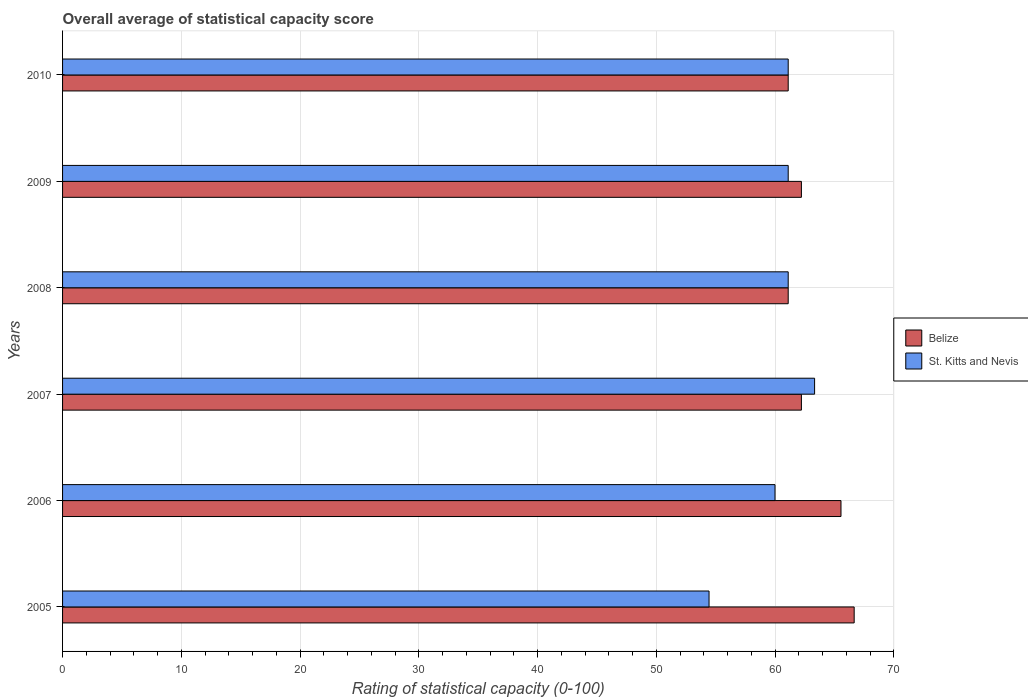How many groups of bars are there?
Provide a succinct answer. 6. Are the number of bars per tick equal to the number of legend labels?
Provide a short and direct response. Yes. Are the number of bars on each tick of the Y-axis equal?
Provide a succinct answer. Yes. How many bars are there on the 2nd tick from the top?
Provide a succinct answer. 2. How many bars are there on the 3rd tick from the bottom?
Your answer should be compact. 2. What is the label of the 4th group of bars from the top?
Keep it short and to the point. 2007. In how many cases, is the number of bars for a given year not equal to the number of legend labels?
Make the answer very short. 0. What is the rating of statistical capacity in St. Kitts and Nevis in 2008?
Provide a short and direct response. 61.11. Across all years, what is the maximum rating of statistical capacity in Belize?
Your answer should be very brief. 66.67. Across all years, what is the minimum rating of statistical capacity in Belize?
Give a very brief answer. 61.11. What is the total rating of statistical capacity in St. Kitts and Nevis in the graph?
Offer a very short reply. 361.11. What is the difference between the rating of statistical capacity in Belize in 2005 and that in 2008?
Your response must be concise. 5.56. What is the difference between the rating of statistical capacity in Belize in 2010 and the rating of statistical capacity in St. Kitts and Nevis in 2008?
Offer a very short reply. 0. What is the average rating of statistical capacity in Belize per year?
Your answer should be very brief. 63.15. In the year 2010, what is the difference between the rating of statistical capacity in Belize and rating of statistical capacity in St. Kitts and Nevis?
Ensure brevity in your answer.  0. What is the ratio of the rating of statistical capacity in Belize in 2005 to that in 2006?
Provide a short and direct response. 1.02. What is the difference between the highest and the second highest rating of statistical capacity in Belize?
Give a very brief answer. 1.11. What is the difference between the highest and the lowest rating of statistical capacity in St. Kitts and Nevis?
Keep it short and to the point. 8.89. What does the 2nd bar from the top in 2006 represents?
Your answer should be compact. Belize. What does the 2nd bar from the bottom in 2010 represents?
Keep it short and to the point. St. Kitts and Nevis. Are all the bars in the graph horizontal?
Keep it short and to the point. Yes. Are the values on the major ticks of X-axis written in scientific E-notation?
Offer a very short reply. No. Does the graph contain any zero values?
Your answer should be very brief. No. Does the graph contain grids?
Your answer should be compact. Yes. Where does the legend appear in the graph?
Ensure brevity in your answer.  Center right. How many legend labels are there?
Your answer should be very brief. 2. What is the title of the graph?
Provide a short and direct response. Overall average of statistical capacity score. Does "Puerto Rico" appear as one of the legend labels in the graph?
Make the answer very short. No. What is the label or title of the X-axis?
Provide a short and direct response. Rating of statistical capacity (0-100). What is the label or title of the Y-axis?
Provide a succinct answer. Years. What is the Rating of statistical capacity (0-100) of Belize in 2005?
Provide a succinct answer. 66.67. What is the Rating of statistical capacity (0-100) of St. Kitts and Nevis in 2005?
Offer a very short reply. 54.44. What is the Rating of statistical capacity (0-100) of Belize in 2006?
Provide a short and direct response. 65.56. What is the Rating of statistical capacity (0-100) of Belize in 2007?
Make the answer very short. 62.22. What is the Rating of statistical capacity (0-100) in St. Kitts and Nevis in 2007?
Your response must be concise. 63.33. What is the Rating of statistical capacity (0-100) in Belize in 2008?
Keep it short and to the point. 61.11. What is the Rating of statistical capacity (0-100) in St. Kitts and Nevis in 2008?
Provide a succinct answer. 61.11. What is the Rating of statistical capacity (0-100) of Belize in 2009?
Ensure brevity in your answer.  62.22. What is the Rating of statistical capacity (0-100) in St. Kitts and Nevis in 2009?
Provide a succinct answer. 61.11. What is the Rating of statistical capacity (0-100) of Belize in 2010?
Ensure brevity in your answer.  61.11. What is the Rating of statistical capacity (0-100) in St. Kitts and Nevis in 2010?
Your answer should be very brief. 61.11. Across all years, what is the maximum Rating of statistical capacity (0-100) of Belize?
Provide a succinct answer. 66.67. Across all years, what is the maximum Rating of statistical capacity (0-100) of St. Kitts and Nevis?
Ensure brevity in your answer.  63.33. Across all years, what is the minimum Rating of statistical capacity (0-100) in Belize?
Offer a terse response. 61.11. Across all years, what is the minimum Rating of statistical capacity (0-100) in St. Kitts and Nevis?
Provide a short and direct response. 54.44. What is the total Rating of statistical capacity (0-100) of Belize in the graph?
Offer a very short reply. 378.89. What is the total Rating of statistical capacity (0-100) in St. Kitts and Nevis in the graph?
Keep it short and to the point. 361.11. What is the difference between the Rating of statistical capacity (0-100) of St. Kitts and Nevis in 2005 and that in 2006?
Your answer should be very brief. -5.56. What is the difference between the Rating of statistical capacity (0-100) of Belize in 2005 and that in 2007?
Ensure brevity in your answer.  4.44. What is the difference between the Rating of statistical capacity (0-100) of St. Kitts and Nevis in 2005 and that in 2007?
Your answer should be very brief. -8.89. What is the difference between the Rating of statistical capacity (0-100) in Belize in 2005 and that in 2008?
Offer a terse response. 5.56. What is the difference between the Rating of statistical capacity (0-100) of St. Kitts and Nevis in 2005 and that in 2008?
Keep it short and to the point. -6.67. What is the difference between the Rating of statistical capacity (0-100) in Belize in 2005 and that in 2009?
Offer a terse response. 4.44. What is the difference between the Rating of statistical capacity (0-100) in St. Kitts and Nevis in 2005 and that in 2009?
Your response must be concise. -6.67. What is the difference between the Rating of statistical capacity (0-100) of Belize in 2005 and that in 2010?
Give a very brief answer. 5.56. What is the difference between the Rating of statistical capacity (0-100) of St. Kitts and Nevis in 2005 and that in 2010?
Ensure brevity in your answer.  -6.67. What is the difference between the Rating of statistical capacity (0-100) in Belize in 2006 and that in 2008?
Keep it short and to the point. 4.44. What is the difference between the Rating of statistical capacity (0-100) of St. Kitts and Nevis in 2006 and that in 2008?
Ensure brevity in your answer.  -1.11. What is the difference between the Rating of statistical capacity (0-100) in St. Kitts and Nevis in 2006 and that in 2009?
Give a very brief answer. -1.11. What is the difference between the Rating of statistical capacity (0-100) in Belize in 2006 and that in 2010?
Give a very brief answer. 4.44. What is the difference between the Rating of statistical capacity (0-100) in St. Kitts and Nevis in 2006 and that in 2010?
Provide a succinct answer. -1.11. What is the difference between the Rating of statistical capacity (0-100) in St. Kitts and Nevis in 2007 and that in 2008?
Offer a very short reply. 2.22. What is the difference between the Rating of statistical capacity (0-100) of Belize in 2007 and that in 2009?
Your answer should be compact. 0. What is the difference between the Rating of statistical capacity (0-100) in St. Kitts and Nevis in 2007 and that in 2009?
Your response must be concise. 2.22. What is the difference between the Rating of statistical capacity (0-100) of St. Kitts and Nevis in 2007 and that in 2010?
Your answer should be very brief. 2.22. What is the difference between the Rating of statistical capacity (0-100) of Belize in 2008 and that in 2009?
Give a very brief answer. -1.11. What is the difference between the Rating of statistical capacity (0-100) of St. Kitts and Nevis in 2008 and that in 2009?
Your answer should be very brief. 0. What is the difference between the Rating of statistical capacity (0-100) of St. Kitts and Nevis in 2008 and that in 2010?
Keep it short and to the point. 0. What is the difference between the Rating of statistical capacity (0-100) in Belize in 2009 and that in 2010?
Keep it short and to the point. 1.11. What is the difference between the Rating of statistical capacity (0-100) in St. Kitts and Nevis in 2009 and that in 2010?
Ensure brevity in your answer.  0. What is the difference between the Rating of statistical capacity (0-100) in Belize in 2005 and the Rating of statistical capacity (0-100) in St. Kitts and Nevis in 2006?
Your response must be concise. 6.67. What is the difference between the Rating of statistical capacity (0-100) of Belize in 2005 and the Rating of statistical capacity (0-100) of St. Kitts and Nevis in 2007?
Ensure brevity in your answer.  3.33. What is the difference between the Rating of statistical capacity (0-100) in Belize in 2005 and the Rating of statistical capacity (0-100) in St. Kitts and Nevis in 2008?
Your answer should be compact. 5.56. What is the difference between the Rating of statistical capacity (0-100) of Belize in 2005 and the Rating of statistical capacity (0-100) of St. Kitts and Nevis in 2009?
Keep it short and to the point. 5.56. What is the difference between the Rating of statistical capacity (0-100) in Belize in 2005 and the Rating of statistical capacity (0-100) in St. Kitts and Nevis in 2010?
Ensure brevity in your answer.  5.56. What is the difference between the Rating of statistical capacity (0-100) of Belize in 2006 and the Rating of statistical capacity (0-100) of St. Kitts and Nevis in 2007?
Your answer should be very brief. 2.22. What is the difference between the Rating of statistical capacity (0-100) of Belize in 2006 and the Rating of statistical capacity (0-100) of St. Kitts and Nevis in 2008?
Your response must be concise. 4.44. What is the difference between the Rating of statistical capacity (0-100) of Belize in 2006 and the Rating of statistical capacity (0-100) of St. Kitts and Nevis in 2009?
Give a very brief answer. 4.44. What is the difference between the Rating of statistical capacity (0-100) of Belize in 2006 and the Rating of statistical capacity (0-100) of St. Kitts and Nevis in 2010?
Provide a succinct answer. 4.44. What is the difference between the Rating of statistical capacity (0-100) in Belize in 2007 and the Rating of statistical capacity (0-100) in St. Kitts and Nevis in 2009?
Your answer should be very brief. 1.11. What is the difference between the Rating of statistical capacity (0-100) of Belize in 2008 and the Rating of statistical capacity (0-100) of St. Kitts and Nevis in 2009?
Make the answer very short. 0. What is the difference between the Rating of statistical capacity (0-100) in Belize in 2009 and the Rating of statistical capacity (0-100) in St. Kitts and Nevis in 2010?
Your answer should be very brief. 1.11. What is the average Rating of statistical capacity (0-100) in Belize per year?
Offer a terse response. 63.15. What is the average Rating of statistical capacity (0-100) of St. Kitts and Nevis per year?
Make the answer very short. 60.19. In the year 2005, what is the difference between the Rating of statistical capacity (0-100) of Belize and Rating of statistical capacity (0-100) of St. Kitts and Nevis?
Provide a short and direct response. 12.22. In the year 2006, what is the difference between the Rating of statistical capacity (0-100) of Belize and Rating of statistical capacity (0-100) of St. Kitts and Nevis?
Provide a succinct answer. 5.56. In the year 2007, what is the difference between the Rating of statistical capacity (0-100) of Belize and Rating of statistical capacity (0-100) of St. Kitts and Nevis?
Give a very brief answer. -1.11. In the year 2010, what is the difference between the Rating of statistical capacity (0-100) of Belize and Rating of statistical capacity (0-100) of St. Kitts and Nevis?
Give a very brief answer. 0. What is the ratio of the Rating of statistical capacity (0-100) of Belize in 2005 to that in 2006?
Give a very brief answer. 1.02. What is the ratio of the Rating of statistical capacity (0-100) in St. Kitts and Nevis in 2005 to that in 2006?
Your response must be concise. 0.91. What is the ratio of the Rating of statistical capacity (0-100) of Belize in 2005 to that in 2007?
Your answer should be compact. 1.07. What is the ratio of the Rating of statistical capacity (0-100) in St. Kitts and Nevis in 2005 to that in 2007?
Offer a very short reply. 0.86. What is the ratio of the Rating of statistical capacity (0-100) in Belize in 2005 to that in 2008?
Provide a short and direct response. 1.09. What is the ratio of the Rating of statistical capacity (0-100) in St. Kitts and Nevis in 2005 to that in 2008?
Provide a short and direct response. 0.89. What is the ratio of the Rating of statistical capacity (0-100) in Belize in 2005 to that in 2009?
Offer a very short reply. 1.07. What is the ratio of the Rating of statistical capacity (0-100) in St. Kitts and Nevis in 2005 to that in 2009?
Give a very brief answer. 0.89. What is the ratio of the Rating of statistical capacity (0-100) of St. Kitts and Nevis in 2005 to that in 2010?
Make the answer very short. 0.89. What is the ratio of the Rating of statistical capacity (0-100) of Belize in 2006 to that in 2007?
Your answer should be compact. 1.05. What is the ratio of the Rating of statistical capacity (0-100) in St. Kitts and Nevis in 2006 to that in 2007?
Give a very brief answer. 0.95. What is the ratio of the Rating of statistical capacity (0-100) of Belize in 2006 to that in 2008?
Provide a short and direct response. 1.07. What is the ratio of the Rating of statistical capacity (0-100) in St. Kitts and Nevis in 2006 to that in 2008?
Keep it short and to the point. 0.98. What is the ratio of the Rating of statistical capacity (0-100) of Belize in 2006 to that in 2009?
Make the answer very short. 1.05. What is the ratio of the Rating of statistical capacity (0-100) of St. Kitts and Nevis in 2006 to that in 2009?
Make the answer very short. 0.98. What is the ratio of the Rating of statistical capacity (0-100) of Belize in 2006 to that in 2010?
Provide a short and direct response. 1.07. What is the ratio of the Rating of statistical capacity (0-100) in St. Kitts and Nevis in 2006 to that in 2010?
Offer a very short reply. 0.98. What is the ratio of the Rating of statistical capacity (0-100) of Belize in 2007 to that in 2008?
Make the answer very short. 1.02. What is the ratio of the Rating of statistical capacity (0-100) of St. Kitts and Nevis in 2007 to that in 2008?
Ensure brevity in your answer.  1.04. What is the ratio of the Rating of statistical capacity (0-100) of Belize in 2007 to that in 2009?
Provide a succinct answer. 1. What is the ratio of the Rating of statistical capacity (0-100) in St. Kitts and Nevis in 2007 to that in 2009?
Keep it short and to the point. 1.04. What is the ratio of the Rating of statistical capacity (0-100) of Belize in 2007 to that in 2010?
Your answer should be very brief. 1.02. What is the ratio of the Rating of statistical capacity (0-100) of St. Kitts and Nevis in 2007 to that in 2010?
Make the answer very short. 1.04. What is the ratio of the Rating of statistical capacity (0-100) of Belize in 2008 to that in 2009?
Provide a short and direct response. 0.98. What is the ratio of the Rating of statistical capacity (0-100) in St. Kitts and Nevis in 2008 to that in 2009?
Make the answer very short. 1. What is the ratio of the Rating of statistical capacity (0-100) in Belize in 2008 to that in 2010?
Give a very brief answer. 1. What is the ratio of the Rating of statistical capacity (0-100) of Belize in 2009 to that in 2010?
Offer a very short reply. 1.02. What is the difference between the highest and the second highest Rating of statistical capacity (0-100) in St. Kitts and Nevis?
Provide a succinct answer. 2.22. What is the difference between the highest and the lowest Rating of statistical capacity (0-100) of Belize?
Your answer should be compact. 5.56. What is the difference between the highest and the lowest Rating of statistical capacity (0-100) of St. Kitts and Nevis?
Make the answer very short. 8.89. 